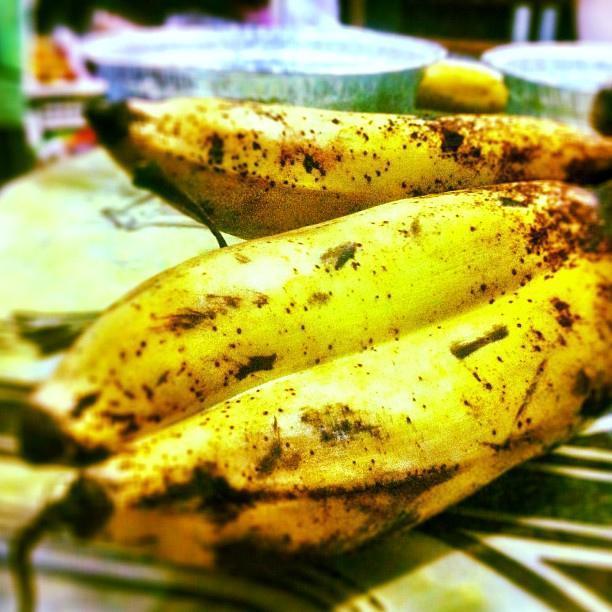How many bananas can be seen?
Give a very brief answer. 3. How many bowls are there?
Give a very brief answer. 2. How many black dogs are there?
Give a very brief answer. 0. 